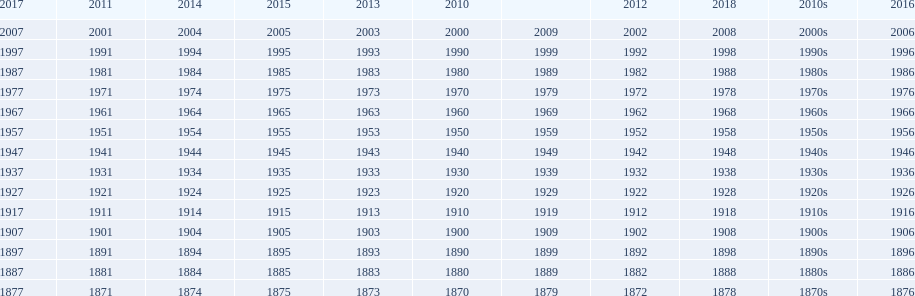Mathematically speaking, what is the difference between 2015 and 1912? 103. 